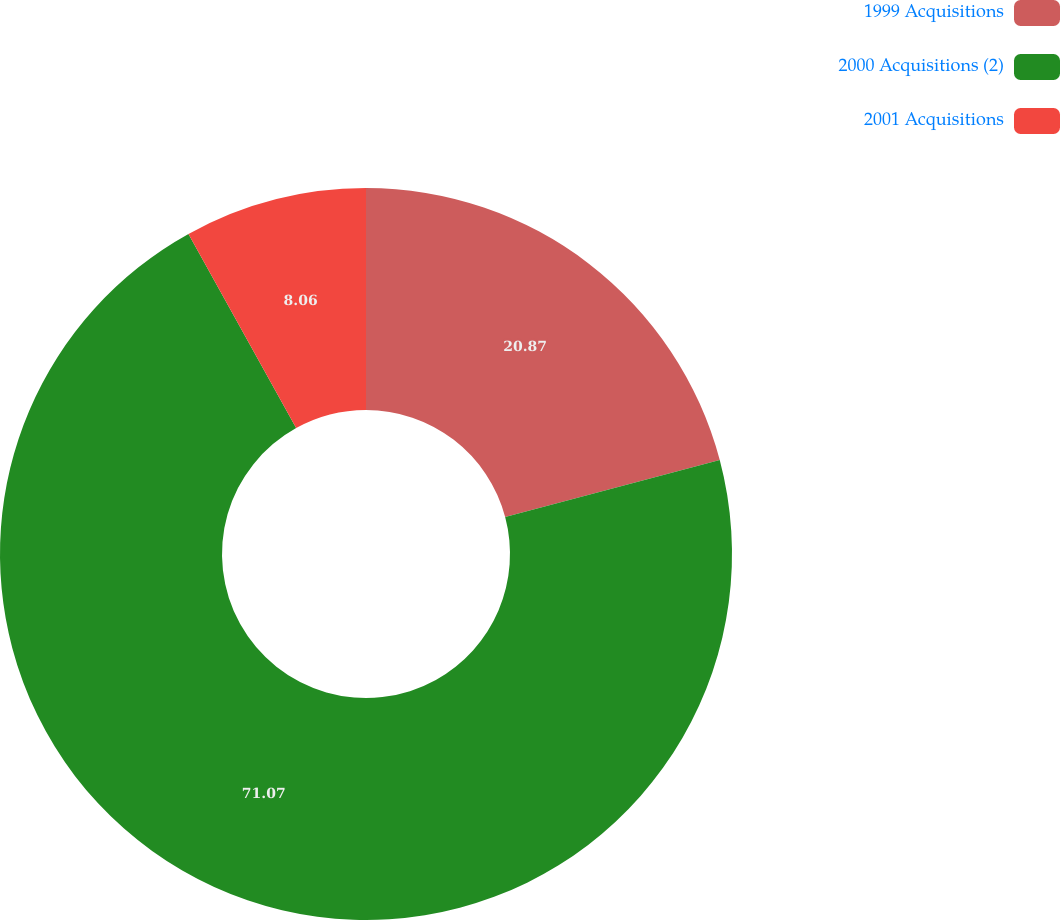Convert chart. <chart><loc_0><loc_0><loc_500><loc_500><pie_chart><fcel>1999 Acquisitions<fcel>2000 Acquisitions (2)<fcel>2001 Acquisitions<nl><fcel>20.87%<fcel>71.07%<fcel>8.06%<nl></chart> 